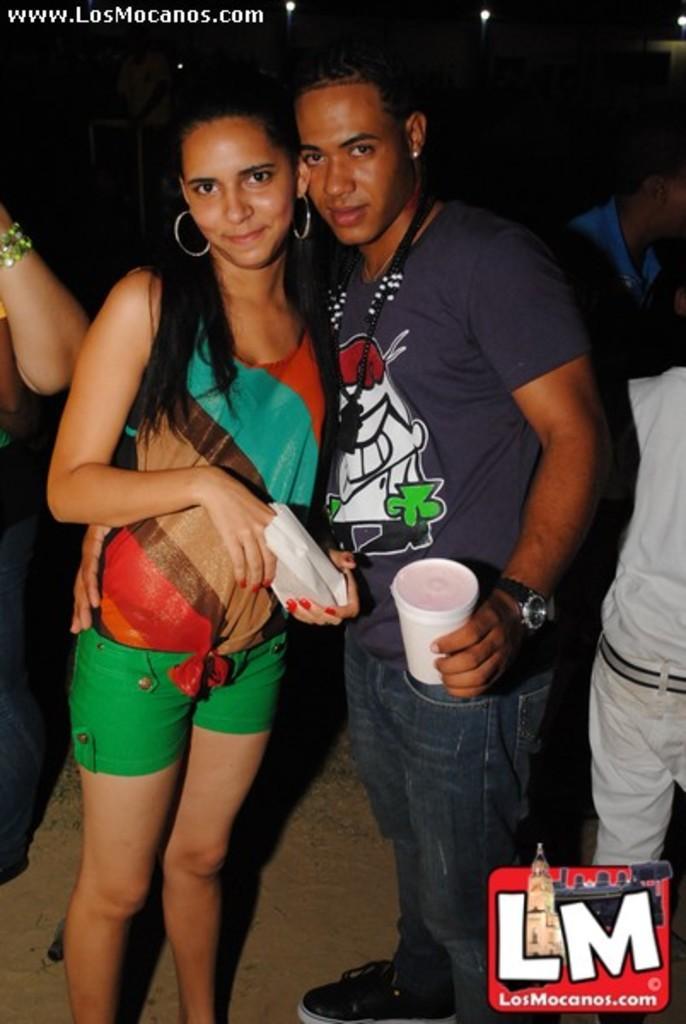Please provide a concise description of this image. In this image we can see a woman and a man. The woman is wearing, colorful top with green shorts and holding a paper bag in her hand. The man is wearing T-shirt, jeans, watch and holding white color glass in his hand. On the right side of the image, we can see people. In the right bottom of the image, there is a watermark. We can see one more person on the left side of the image. 